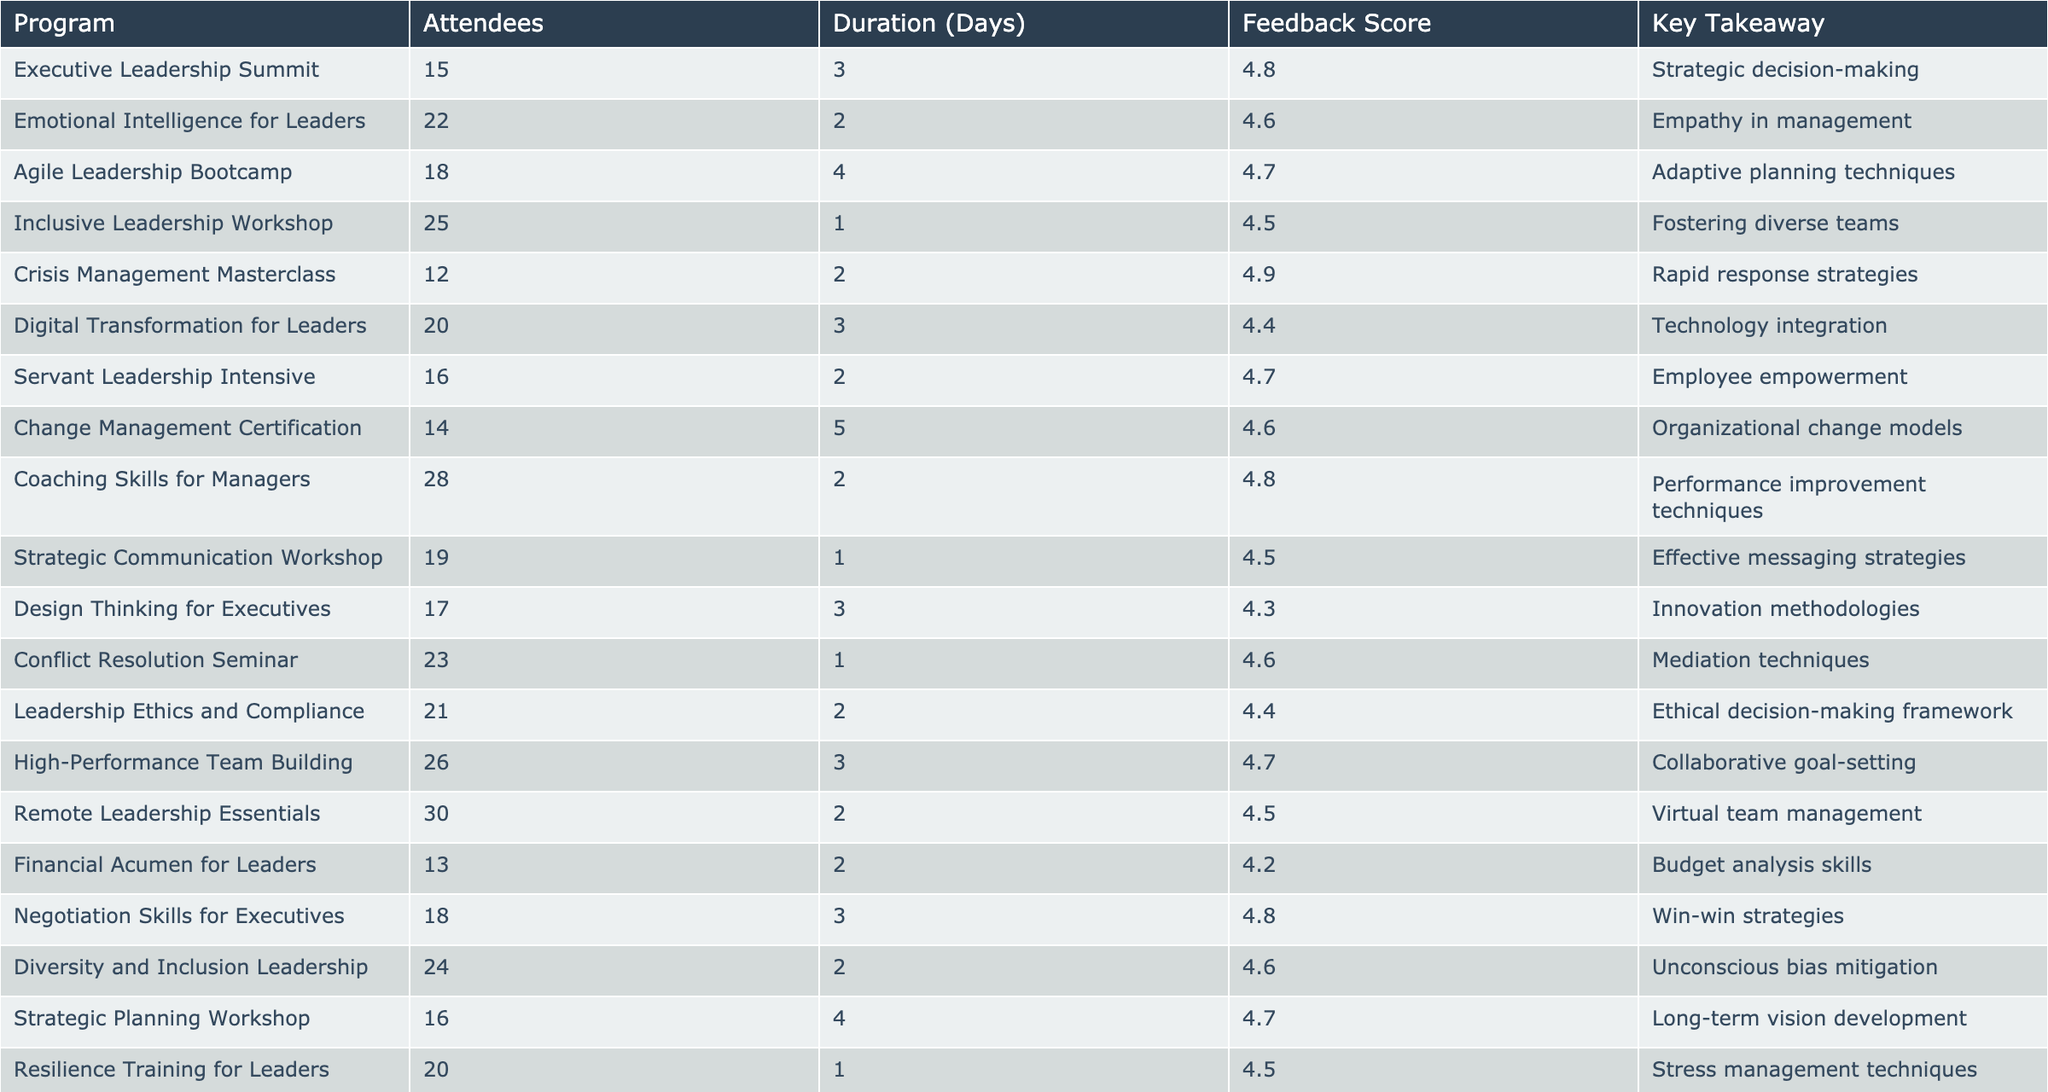What is the feedback score for the Crisis Management Masterclass? The table shows the row for the Crisis Management Masterclass, and the Feedback Score in that row is 4.9.
Answer: 4.9 Which program had the highest attendance? By reviewing the "Attendees" column, the program with the highest attendance is Remote Leadership Essentials with 30 attendees.
Answer: Remote Leadership Essentials What is the average feedback score for all programs? To calculate the average, sum all feedback scores (4.8 + 4.6 + 4.7 + 4.5 + 4.9 + 4.4 + 4.7 + 4.6 + 4.8 + 4.5 + 4.3 + 4.6 + 4.4 + 4.7 + 4.5 + 4.2 + 4.8 + 4.6 + 4.7 + 4.5) which equals 94.4, then divide by the number of programs (20) to get the average of 94.4/20 = 4.72.
Answer: 4.72 How many programs had a feedback score of 4.6 or higher? Counting the programs with scores 4.6 or higher, we have 14 such programs.
Answer: 14 Is the duration of the Emotional Intelligence for Leaders program longer than the Leadership Ethics and Compliance program? The Emotional Intelligence for Leaders program lasts 2 days while the Leadership Ethics and Compliance program also lasts 2 days. Thus, they are equal; one is not longer than the other.
Answer: No What is the total number of attendees in programs lasting 2 days? The attendees from 2-day programs are: Emotional Intelligence for Leaders (22), Crisis Management Masterclass (12), Servant Leadership Intensive (16), Financial Acumen for Leaders (13), Leadership Ethics and Compliance (21), Coaching Skills for Managers (28), and Diversity and Inclusion Leadership (24), totaling 22 + 12 + 16 + 13 + 21 + 28 + 24 = 136.
Answer: 136 What is the key takeaway from the Coaching Skills for Managers program? Referring to the Coaching Skills for Managers row, the key takeaway is Performance improvement techniques.
Answer: Performance improvement techniques Which program has the lowest feedback score, and what is the score? The program with the lowest feedback score is Financial Acumen for Leaders with a score of 4.2.
Answer: Financial Acumen for Leaders, 4.2 How many programs focused on leadership ethics and compliance topics? Looking through the table, two programs focus on ethics: Leadership Ethics and Compliance, and Servant Leadership Intensive.
Answer: 2 Which program had the longest duration, and what was its duration? The program with the longest duration is Change Management Certification, which lasts 5 days.
Answer: Change Management Certification, 5 days 